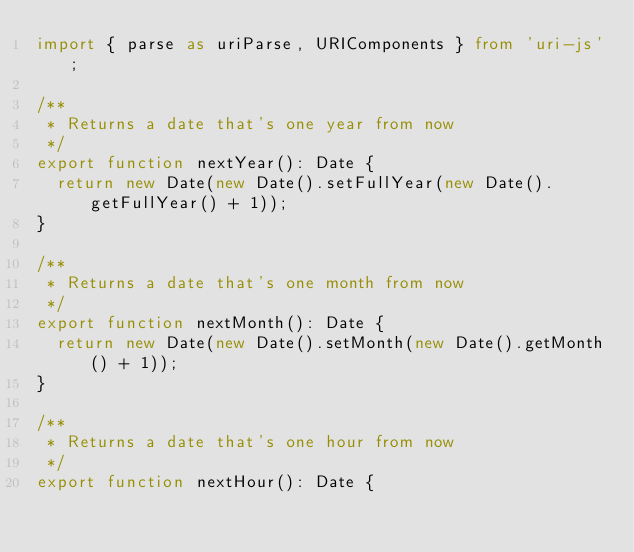Convert code to text. <code><loc_0><loc_0><loc_500><loc_500><_TypeScript_>import { parse as uriParse, URIComponents } from 'uri-js';

/**
 * Returns a date that's one year from now
 */
export function nextYear(): Date {
	return new Date(new Date().setFullYear(new Date().getFullYear() + 1));
}

/**
 * Returns a date that's one month from now
 */
export function nextMonth(): Date {
	return new Date(new Date().setMonth(new Date().getMonth() + 1));
}

/**
 * Returns a date that's one hour from now
 */
export function nextHour(): Date {</code> 